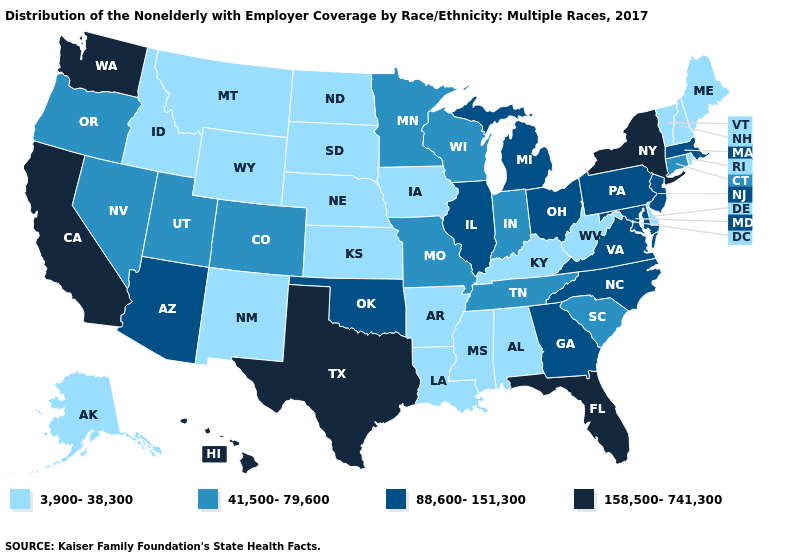What is the value of Washington?
Concise answer only. 158,500-741,300. Among the states that border Ohio , which have the highest value?
Answer briefly. Michigan, Pennsylvania. Which states have the lowest value in the USA?
Concise answer only. Alabama, Alaska, Arkansas, Delaware, Idaho, Iowa, Kansas, Kentucky, Louisiana, Maine, Mississippi, Montana, Nebraska, New Hampshire, New Mexico, North Dakota, Rhode Island, South Dakota, Vermont, West Virginia, Wyoming. Does Texas have the highest value in the USA?
Concise answer only. Yes. Name the states that have a value in the range 158,500-741,300?
Keep it brief. California, Florida, Hawaii, New York, Texas, Washington. What is the value of Arizona?
Answer briefly. 88,600-151,300. What is the lowest value in the Northeast?
Be succinct. 3,900-38,300. Which states have the highest value in the USA?
Be succinct. California, Florida, Hawaii, New York, Texas, Washington. Among the states that border Utah , which have the highest value?
Quick response, please. Arizona. What is the value of New Jersey?
Be succinct. 88,600-151,300. Which states have the highest value in the USA?
Write a very short answer. California, Florida, Hawaii, New York, Texas, Washington. What is the value of Idaho?
Concise answer only. 3,900-38,300. Does the first symbol in the legend represent the smallest category?
Write a very short answer. Yes. What is the value of Virginia?
Short answer required. 88,600-151,300. What is the highest value in the USA?
Quick response, please. 158,500-741,300. 